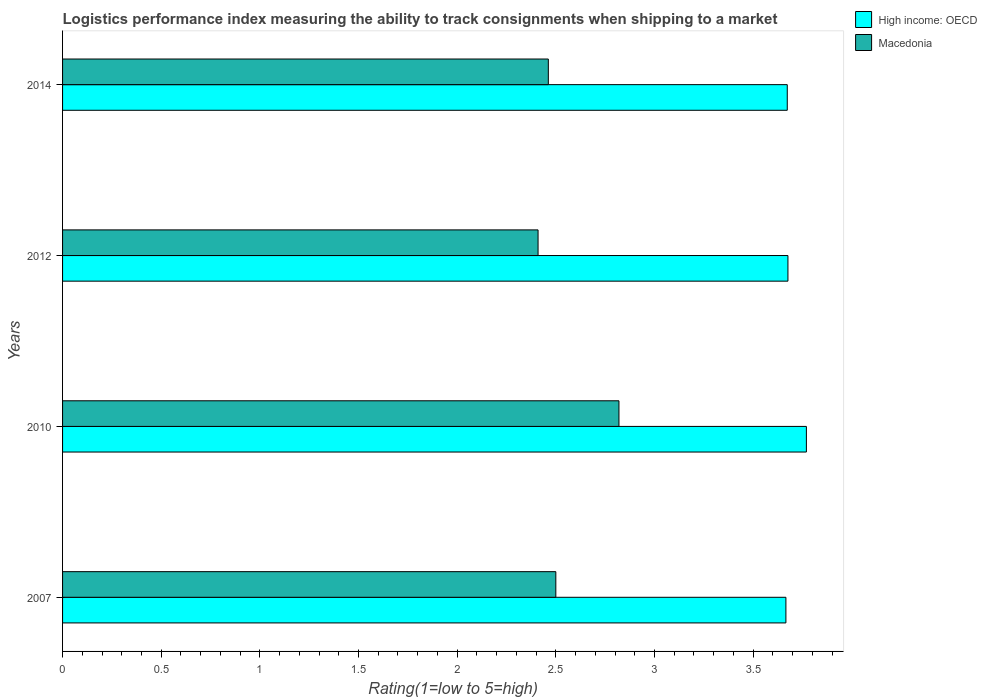How many different coloured bars are there?
Make the answer very short. 2. Are the number of bars per tick equal to the number of legend labels?
Offer a very short reply. Yes. Are the number of bars on each tick of the Y-axis equal?
Give a very brief answer. Yes. How many bars are there on the 3rd tick from the bottom?
Make the answer very short. 2. In how many cases, is the number of bars for a given year not equal to the number of legend labels?
Offer a terse response. 0. Across all years, what is the maximum Logistic performance index in High income: OECD?
Your answer should be very brief. 3.77. Across all years, what is the minimum Logistic performance index in High income: OECD?
Keep it short and to the point. 3.67. What is the total Logistic performance index in High income: OECD in the graph?
Your answer should be compact. 14.79. What is the difference between the Logistic performance index in Macedonia in 2010 and that in 2014?
Offer a terse response. 0.36. What is the difference between the Logistic performance index in Macedonia in 2010 and the Logistic performance index in High income: OECD in 2012?
Give a very brief answer. -0.86. What is the average Logistic performance index in Macedonia per year?
Offer a very short reply. 2.55. In the year 2010, what is the difference between the Logistic performance index in Macedonia and Logistic performance index in High income: OECD?
Give a very brief answer. -0.95. What is the ratio of the Logistic performance index in High income: OECD in 2007 to that in 2012?
Give a very brief answer. 1. Is the Logistic performance index in High income: OECD in 2010 less than that in 2014?
Give a very brief answer. No. What is the difference between the highest and the second highest Logistic performance index in Macedonia?
Ensure brevity in your answer.  0.32. What is the difference between the highest and the lowest Logistic performance index in High income: OECD?
Your answer should be very brief. 0.1. In how many years, is the Logistic performance index in Macedonia greater than the average Logistic performance index in Macedonia taken over all years?
Provide a short and direct response. 1. Is the sum of the Logistic performance index in High income: OECD in 2007 and 2010 greater than the maximum Logistic performance index in Macedonia across all years?
Provide a succinct answer. Yes. What does the 1st bar from the top in 2007 represents?
Give a very brief answer. Macedonia. What does the 2nd bar from the bottom in 2007 represents?
Provide a short and direct response. Macedonia. How many bars are there?
Provide a succinct answer. 8. Are all the bars in the graph horizontal?
Keep it short and to the point. Yes. What is the difference between two consecutive major ticks on the X-axis?
Your answer should be compact. 0.5. Are the values on the major ticks of X-axis written in scientific E-notation?
Make the answer very short. No. Does the graph contain any zero values?
Provide a succinct answer. No. Where does the legend appear in the graph?
Give a very brief answer. Top right. How many legend labels are there?
Your answer should be compact. 2. How are the legend labels stacked?
Offer a terse response. Vertical. What is the title of the graph?
Keep it short and to the point. Logistics performance index measuring the ability to track consignments when shipping to a market. Does "Marshall Islands" appear as one of the legend labels in the graph?
Keep it short and to the point. No. What is the label or title of the X-axis?
Your answer should be compact. Rating(1=low to 5=high). What is the Rating(1=low to 5=high) of High income: OECD in 2007?
Your answer should be very brief. 3.67. What is the Rating(1=low to 5=high) in Macedonia in 2007?
Ensure brevity in your answer.  2.5. What is the Rating(1=low to 5=high) of High income: OECD in 2010?
Your answer should be compact. 3.77. What is the Rating(1=low to 5=high) of Macedonia in 2010?
Provide a short and direct response. 2.82. What is the Rating(1=low to 5=high) of High income: OECD in 2012?
Keep it short and to the point. 3.68. What is the Rating(1=low to 5=high) in Macedonia in 2012?
Provide a succinct answer. 2.41. What is the Rating(1=low to 5=high) in High income: OECD in 2014?
Offer a terse response. 3.67. What is the Rating(1=low to 5=high) of Macedonia in 2014?
Offer a terse response. 2.46. Across all years, what is the maximum Rating(1=low to 5=high) in High income: OECD?
Ensure brevity in your answer.  3.77. Across all years, what is the maximum Rating(1=low to 5=high) in Macedonia?
Provide a succinct answer. 2.82. Across all years, what is the minimum Rating(1=low to 5=high) in High income: OECD?
Make the answer very short. 3.67. Across all years, what is the minimum Rating(1=low to 5=high) in Macedonia?
Your response must be concise. 2.41. What is the total Rating(1=low to 5=high) of High income: OECD in the graph?
Your response must be concise. 14.79. What is the total Rating(1=low to 5=high) of Macedonia in the graph?
Give a very brief answer. 10.19. What is the difference between the Rating(1=low to 5=high) of High income: OECD in 2007 and that in 2010?
Give a very brief answer. -0.1. What is the difference between the Rating(1=low to 5=high) in Macedonia in 2007 and that in 2010?
Your answer should be compact. -0.32. What is the difference between the Rating(1=low to 5=high) in High income: OECD in 2007 and that in 2012?
Keep it short and to the point. -0.01. What is the difference between the Rating(1=low to 5=high) in Macedonia in 2007 and that in 2012?
Offer a very short reply. 0.09. What is the difference between the Rating(1=low to 5=high) in High income: OECD in 2007 and that in 2014?
Give a very brief answer. -0.01. What is the difference between the Rating(1=low to 5=high) of Macedonia in 2007 and that in 2014?
Ensure brevity in your answer.  0.04. What is the difference between the Rating(1=low to 5=high) in High income: OECD in 2010 and that in 2012?
Give a very brief answer. 0.09. What is the difference between the Rating(1=low to 5=high) of Macedonia in 2010 and that in 2012?
Your answer should be compact. 0.41. What is the difference between the Rating(1=low to 5=high) of High income: OECD in 2010 and that in 2014?
Keep it short and to the point. 0.1. What is the difference between the Rating(1=low to 5=high) of Macedonia in 2010 and that in 2014?
Offer a very short reply. 0.36. What is the difference between the Rating(1=low to 5=high) in High income: OECD in 2012 and that in 2014?
Provide a succinct answer. 0. What is the difference between the Rating(1=low to 5=high) of Macedonia in 2012 and that in 2014?
Provide a short and direct response. -0.05. What is the difference between the Rating(1=low to 5=high) in High income: OECD in 2007 and the Rating(1=low to 5=high) in Macedonia in 2010?
Give a very brief answer. 0.85. What is the difference between the Rating(1=low to 5=high) of High income: OECD in 2007 and the Rating(1=low to 5=high) of Macedonia in 2012?
Offer a terse response. 1.26. What is the difference between the Rating(1=low to 5=high) of High income: OECD in 2007 and the Rating(1=low to 5=high) of Macedonia in 2014?
Your answer should be very brief. 1.2. What is the difference between the Rating(1=low to 5=high) of High income: OECD in 2010 and the Rating(1=low to 5=high) of Macedonia in 2012?
Your answer should be very brief. 1.36. What is the difference between the Rating(1=low to 5=high) of High income: OECD in 2010 and the Rating(1=low to 5=high) of Macedonia in 2014?
Provide a short and direct response. 1.31. What is the difference between the Rating(1=low to 5=high) of High income: OECD in 2012 and the Rating(1=low to 5=high) of Macedonia in 2014?
Your answer should be compact. 1.21. What is the average Rating(1=low to 5=high) of High income: OECD per year?
Your answer should be very brief. 3.7. What is the average Rating(1=low to 5=high) of Macedonia per year?
Provide a succinct answer. 2.55. In the year 2007, what is the difference between the Rating(1=low to 5=high) in High income: OECD and Rating(1=low to 5=high) in Macedonia?
Keep it short and to the point. 1.17. In the year 2012, what is the difference between the Rating(1=low to 5=high) in High income: OECD and Rating(1=low to 5=high) in Macedonia?
Provide a succinct answer. 1.27. In the year 2014, what is the difference between the Rating(1=low to 5=high) of High income: OECD and Rating(1=low to 5=high) of Macedonia?
Keep it short and to the point. 1.21. What is the ratio of the Rating(1=low to 5=high) of High income: OECD in 2007 to that in 2010?
Offer a very short reply. 0.97. What is the ratio of the Rating(1=low to 5=high) in Macedonia in 2007 to that in 2010?
Your answer should be compact. 0.89. What is the ratio of the Rating(1=low to 5=high) of Macedonia in 2007 to that in 2012?
Keep it short and to the point. 1.04. What is the ratio of the Rating(1=low to 5=high) in High income: OECD in 2007 to that in 2014?
Make the answer very short. 1. What is the ratio of the Rating(1=low to 5=high) of Macedonia in 2007 to that in 2014?
Keep it short and to the point. 1.02. What is the ratio of the Rating(1=low to 5=high) of High income: OECD in 2010 to that in 2012?
Offer a terse response. 1.03. What is the ratio of the Rating(1=low to 5=high) in Macedonia in 2010 to that in 2012?
Keep it short and to the point. 1.17. What is the ratio of the Rating(1=low to 5=high) of High income: OECD in 2010 to that in 2014?
Make the answer very short. 1.03. What is the ratio of the Rating(1=low to 5=high) in Macedonia in 2010 to that in 2014?
Your answer should be very brief. 1.15. What is the ratio of the Rating(1=low to 5=high) in High income: OECD in 2012 to that in 2014?
Offer a terse response. 1. What is the ratio of the Rating(1=low to 5=high) in Macedonia in 2012 to that in 2014?
Provide a short and direct response. 0.98. What is the difference between the highest and the second highest Rating(1=low to 5=high) in High income: OECD?
Your answer should be very brief. 0.09. What is the difference between the highest and the second highest Rating(1=low to 5=high) of Macedonia?
Your answer should be very brief. 0.32. What is the difference between the highest and the lowest Rating(1=low to 5=high) of High income: OECD?
Your answer should be very brief. 0.1. What is the difference between the highest and the lowest Rating(1=low to 5=high) of Macedonia?
Give a very brief answer. 0.41. 